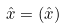Convert formula to latex. <formula><loc_0><loc_0><loc_500><loc_500>\hat { x } = ( \hat { x } ) ^ { }</formula> 